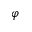Convert formula to latex. <formula><loc_0><loc_0><loc_500><loc_500>\boldsymbol \varphi</formula> 